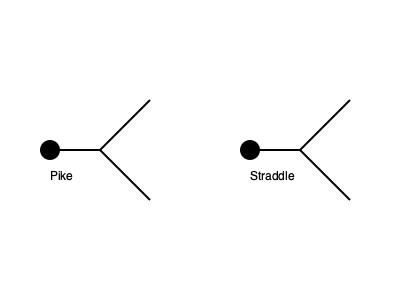In competitive gymnastics, understanding body positions is crucial for both performance and scoring. Consider the two stick figure illustrations above representing a gymnast in pike and straddle positions. If we assume the gymnast's body mass is evenly distributed, how would the center of mass (COM) compare between these two positions? Explain your reasoning and provide a general formula for calculating the COM in a 2D plane. To compare the center of mass (COM) between the pike and straddle positions, we need to consider the distribution of body mass in each position:

1. Pike position:
   - The body is folded at the hips, with legs straight and close to the upper body.
   - Most of the body mass is concentrated near the hips.

2. Straddle position:
   - The legs are spread apart, forming a V-shape with the upper body.
   - The body mass is more evenly distributed along the length of the body.

To calculate the COM in a 2D plane, we use the following formula:

$$ x_{COM} = \frac{\sum_{i=1}^n m_i x_i}{\sum_{i=1}^n m_i} $$
$$ y_{COM} = \frac{\sum_{i=1}^n m_i y_i}{\sum_{i=1}^n m_i} $$

Where:
- $(x_{COM}, y_{COM})$ is the position of the center of mass
- $m_i$ is the mass of each body segment
- $(x_i, y_i)$ is the position of each body segment's center of mass

Comparing the two positions:
1. In the pike position, the COM would be closer to the hips due to the concentration of mass in that area.
2. In the straddle position, the COM would be slightly lower and more centered between the hips and the middle of the torso.

The exact location of the COM in each position would depend on the specific angles of the body segments and the individual gymnast's body proportions. However, generally, the COM in the pike position would be higher and closer to the hips compared to the straddle position.
Answer: The COM in the pike position would be higher and closer to the hips, while in the straddle position, it would be lower and more centered. 